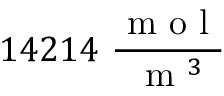Convert formula to latex. <formula><loc_0><loc_0><loc_500><loc_500>1 4 2 1 4 \ \frac { m o l } { m ^ { 3 } }</formula> 